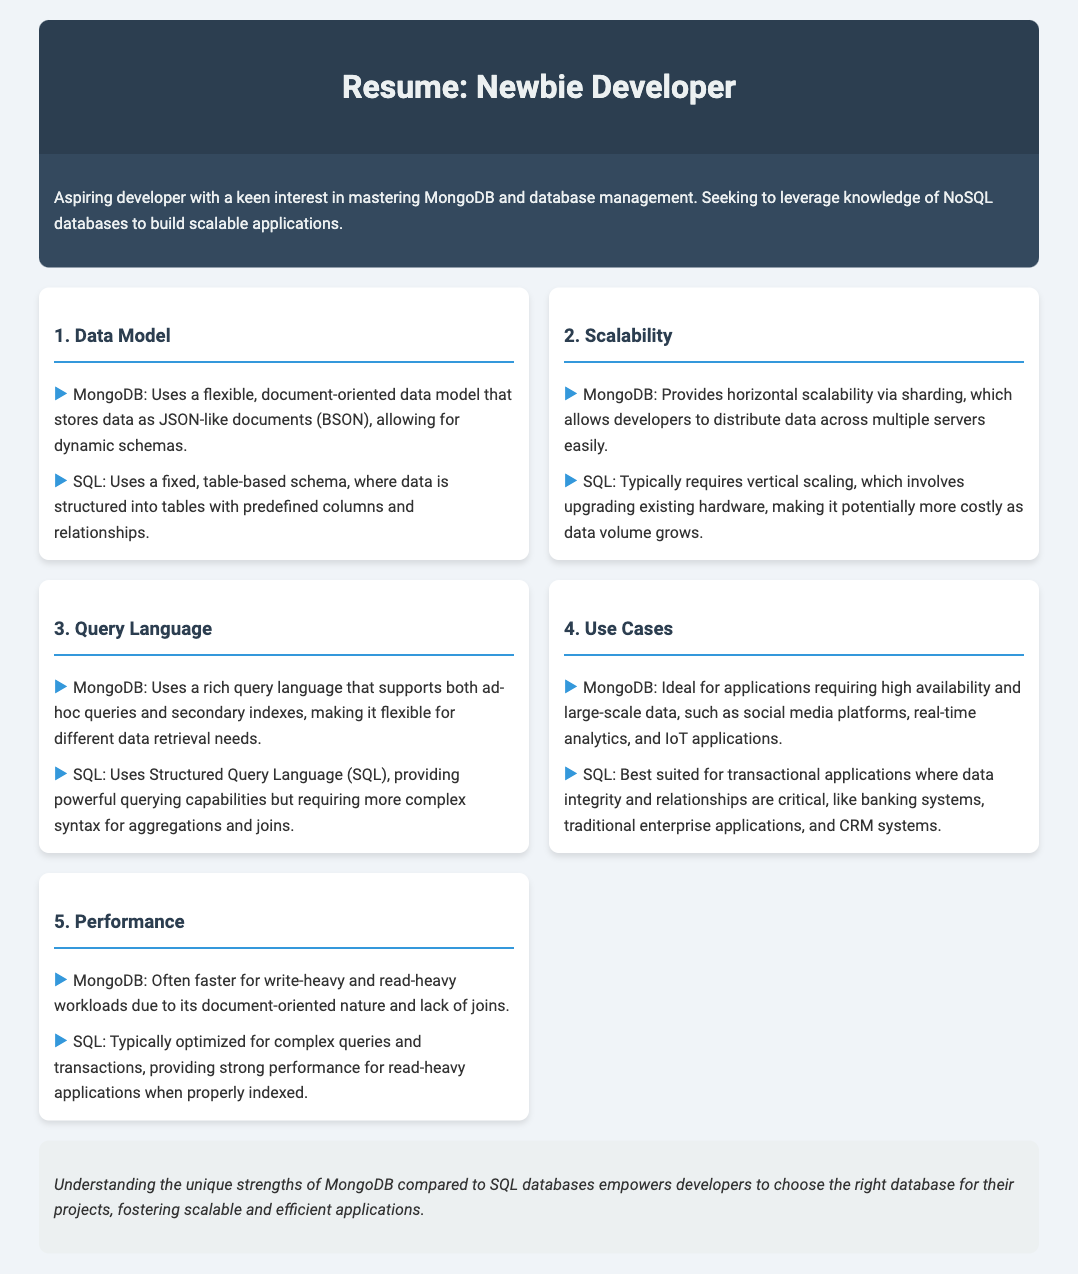What data model does MongoDB use? The document specifies that MongoDB uses a flexible, document-oriented data model that stores data as JSON-like documents (BSON).
Answer: JSON-like documents (BSON) What is a key advantage of MongoDB regarding scalability? According to the document, MongoDB provides horizontal scalability via sharding, allowing data distribution across multiple servers easily.
Answer: Horizontal scalability via sharding What query language does SQL use? The document indicates that SQL uses Structured Query Language (SQL).
Answer: SQL In which applications is MongoDB ideal? The document mentions that MongoDB is ideal for applications requiring high availability and large-scale data.
Answer: Social media platforms, real-time analytics, IoT How does MongoDB perform with write-heavy workloads? The document states that MongoDB is often faster for write-heavy workloads due to its document-oriented nature.
Answer: Faster What is a characteristic of SQL's data structure? The document describes SQL as using a fixed, table-based schema with predefined columns and relationships.
Answer: Fixed, table-based schema Which database is better suited for transactional applications? The document claims that SQL is best suited for transactional applications where data integrity is critical.
Answer: SQL What performance aspect does SQL optimize for? According to the document, SQL typically provides strong performance for read-heavy applications when properly indexed.
Answer: Read-heavy applications What is the conclusion regarding database selection? The document concludes that understanding the unique strengths of MongoDB compared to SQL databases empowers developers to choose the right database for their projects.
Answer: Choose the right database for their projects 